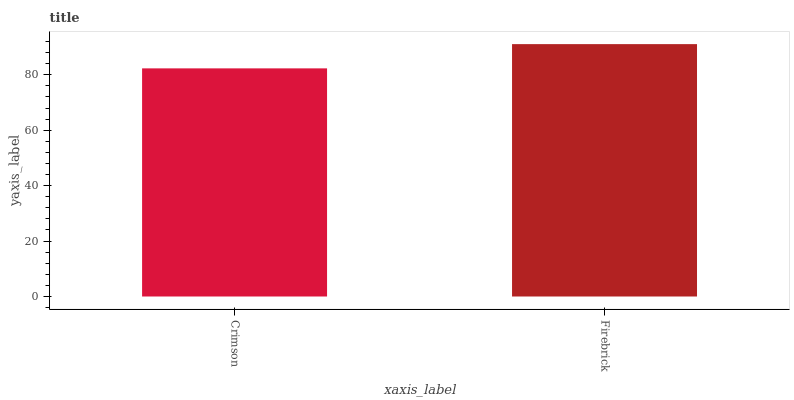Is Crimson the minimum?
Answer yes or no. Yes. Is Firebrick the maximum?
Answer yes or no. Yes. Is Firebrick the minimum?
Answer yes or no. No. Is Firebrick greater than Crimson?
Answer yes or no. Yes. Is Crimson less than Firebrick?
Answer yes or no. Yes. Is Crimson greater than Firebrick?
Answer yes or no. No. Is Firebrick less than Crimson?
Answer yes or no. No. Is Firebrick the high median?
Answer yes or no. Yes. Is Crimson the low median?
Answer yes or no. Yes. Is Crimson the high median?
Answer yes or no. No. Is Firebrick the low median?
Answer yes or no. No. 